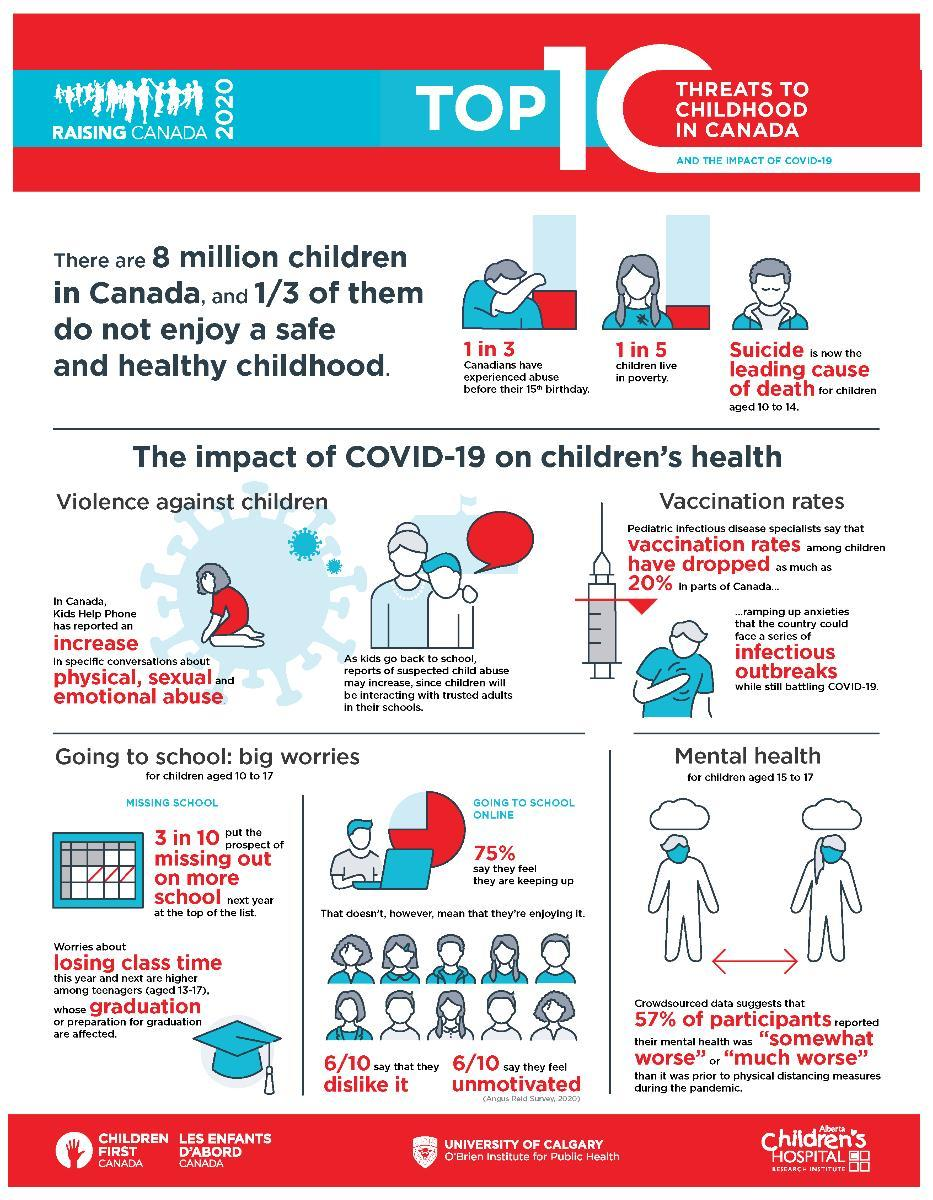What is the fourth point mentioned under "effects of COVID-19 on kids"?
Answer the question with a short phrase. Mental health What is the inverse of percentage of decline of immunisation among infants? 80 What are the different types of misuses faced by children in Canada? physical, sexual, emotional What percent of children were misused before reaching the age of 15? 1 in 3 What percentage of adolescents are poor in Canada? 1 in 5 What is the no of Canadian students who loves to attend online classes? 0.4 How many Canadian students are attending classes online? 75% If taken a sample of 10, how many children said they are lazy to attend online classes? 6/10 What percent of Canadian students are not attending classes online? 25 